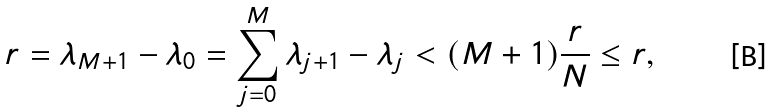<formula> <loc_0><loc_0><loc_500><loc_500>r = \lambda _ { M + 1 } - \lambda _ { 0 } = \sum _ { j = 0 } ^ { M } \lambda _ { j + 1 } - \lambda _ { j } < ( M + 1 ) \frac { r } { N } \leq r ,</formula> 